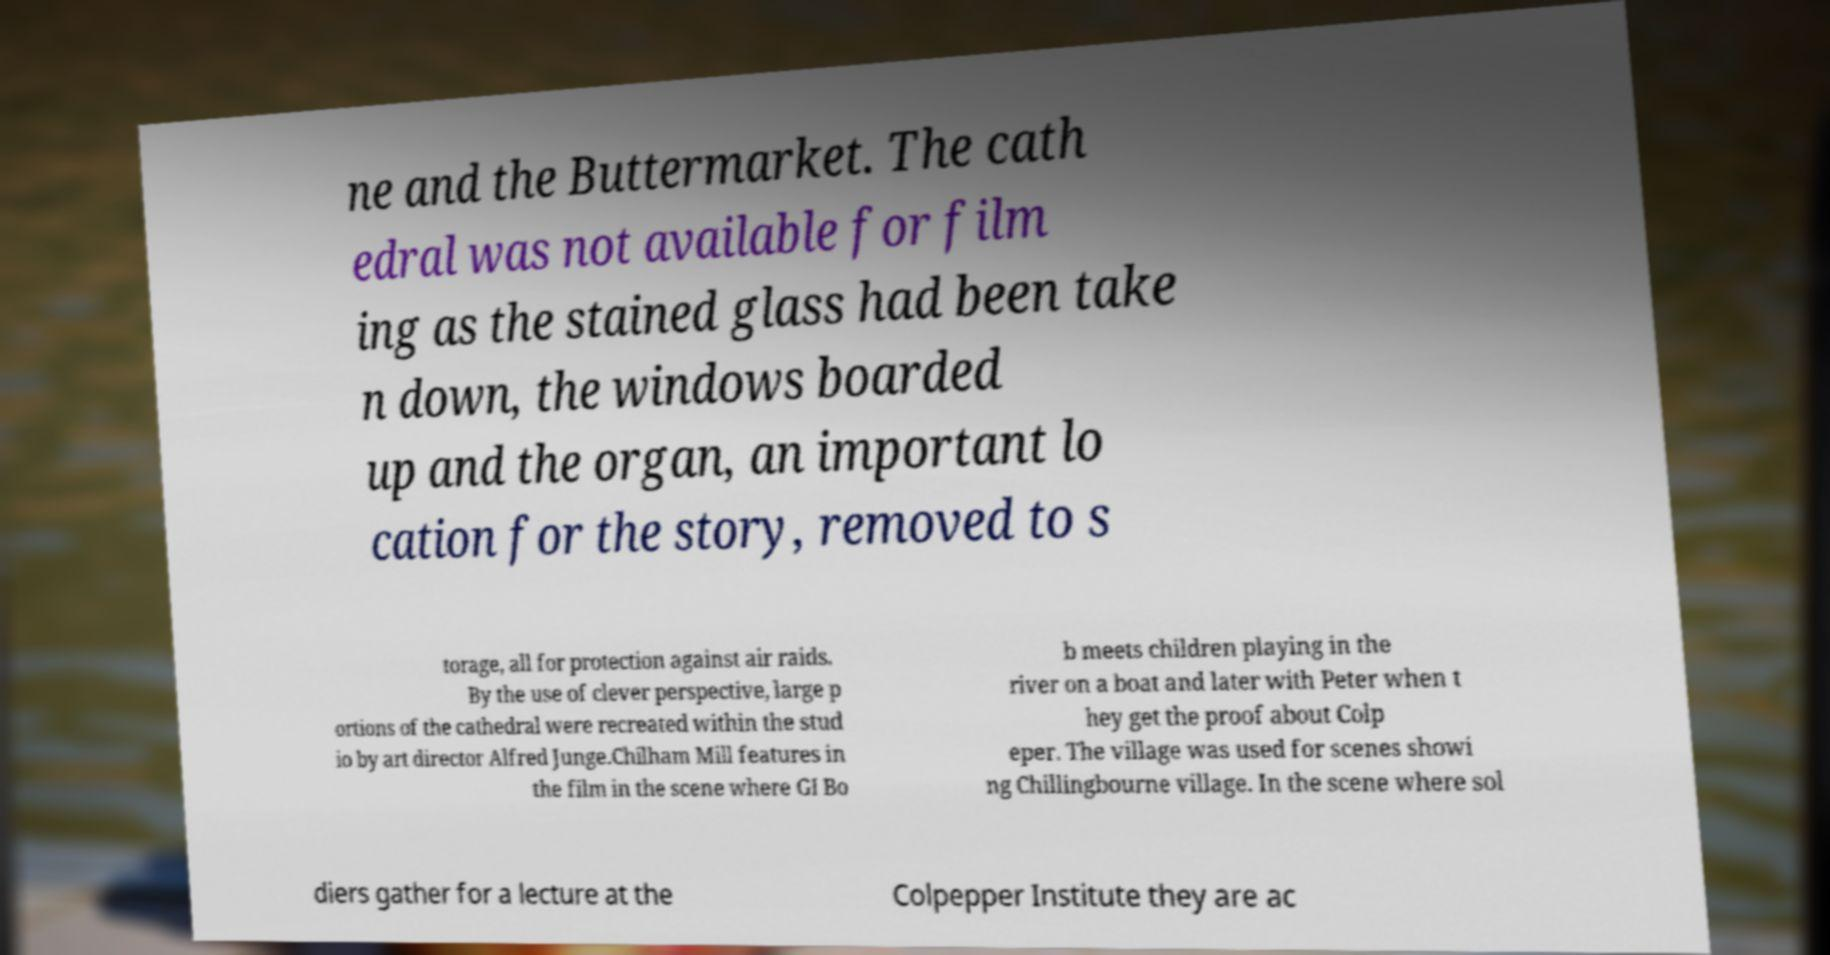Can you accurately transcribe the text from the provided image for me? ne and the Buttermarket. The cath edral was not available for film ing as the stained glass had been take n down, the windows boarded up and the organ, an important lo cation for the story, removed to s torage, all for protection against air raids. By the use of clever perspective, large p ortions of the cathedral were recreated within the stud io by art director Alfred Junge.Chilham Mill features in the film in the scene where GI Bo b meets children playing in the river on a boat and later with Peter when t hey get the proof about Colp eper. The village was used for scenes showi ng Chillingbourne village. In the scene where sol diers gather for a lecture at the Colpepper Institute they are ac 